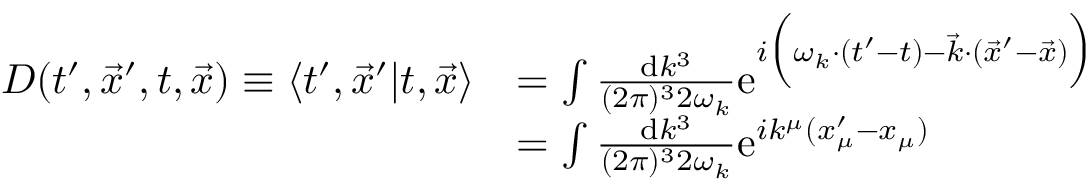<formula> <loc_0><loc_0><loc_500><loc_500>\begin{array} { r l } { D ( t ^ { \prime } , \vec { x } ^ { \prime } , t , \vec { x } ) \equiv \langle { { t ^ { \prime } , \vec { x } ^ { \prime } } | { t , \vec { x } } } \rangle } & { = \int \frac { d k ^ { 3 } } { ( 2 \pi ) ^ { 3 } 2 \omega _ { k } } { e } ^ { i \left ( \omega _ { k } \cdot ( t ^ { \prime } - t ) - \vec { k } \cdot ( \vec { x } ^ { \prime } - \vec { x } ) \right ) } } \\ & { = \int \frac { d k ^ { 3 } } { ( 2 \pi ) ^ { 3 } 2 \omega _ { k } } { e } ^ { i k ^ { \mu } ( x _ { \mu } ^ { \prime } - x _ { \mu } ) } } \end{array}</formula> 